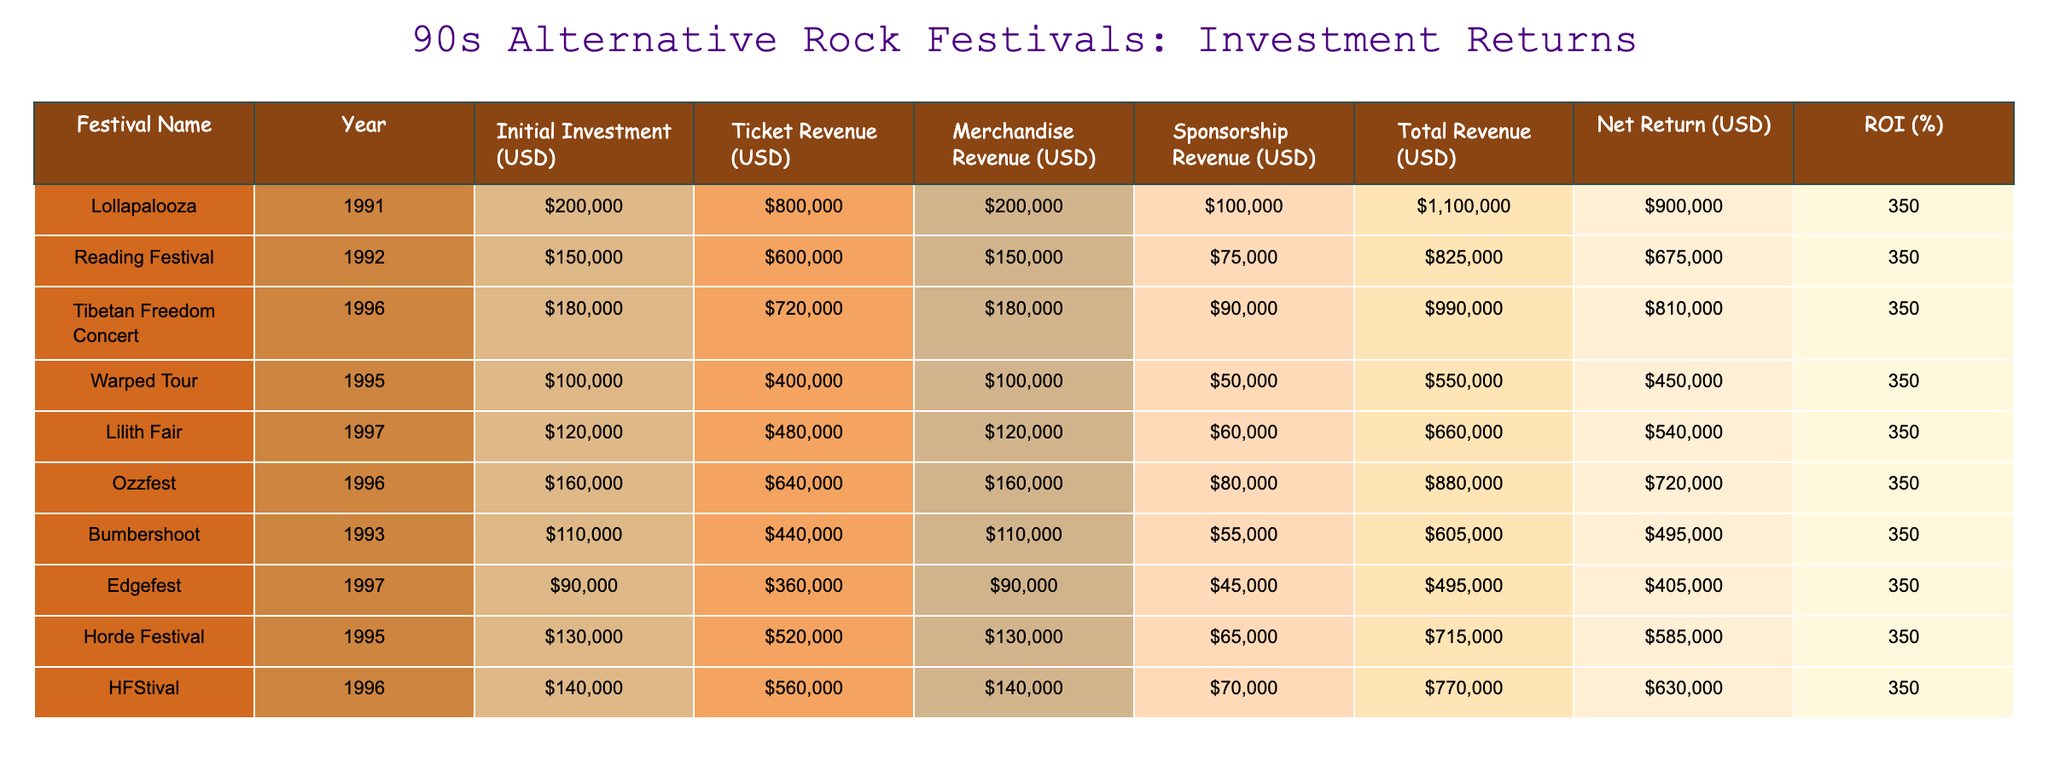What is the highest Net Return among the festivals? By looking at the 'Net Return (USD)' column, we find that Lollapalooza has the highest value at 900,000 USD.
Answer: 900000 Which festival had the lowest Initial Investment? The 'Initial Investment (USD)' column shows that Edgefest had the lowest investment amount at 90,000 USD.
Answer: 90000 What is the average Total Revenue of all the festivals? First, we sum the 'Total Revenue (USD)' values: (1,100,000 + 825,000 + 990,000 + 550,000 + 660,000 + 880,000 + 605,000 + 495,000 + 770,000) = 6,975,000 USD. Since there are 9 festivals, the average is 6,975,000 / 9 = 775,000 USD.
Answer: 775000 Did any festival achieve a Net Return exceeding 600,000 USD? By examining the 'Net Return (USD)' values, we see that Lollapalooza, Reading Festival, Tibetan Freedom Concert, Ozzfest, and Lilith Fair all exceed 600,000 USD, confirming that there are festivals which did achieve this.
Answer: Yes What is the difference in Total Revenue between Lollapalooza and Warped Tour? The Total Revenue for Lollapalooza is 1,100,000 USD and for Warped Tour it is 550,000 USD. The difference is 1,100,000 - 550,000 = 550,000 USD.
Answer: 550000 Which festival had the highest Merchandise Revenue? Looking at the 'Merchandise Revenue (USD)' column, we identify that Ozzfest has the highest amount at 160,000 USD.
Answer: 160000 What was the Total Revenue for the festival with the second highest Net Return? After identifying that Lollapalooza has the highest Net Return and the second highest is Tibetan Freedom Concert at 810,000 USD, the Total Revenue for this festival is 990,000 USD.
Answer: 990000 What percentage of the Initial Investment did Edgefest earn as a return? Edgefest's Net Return is 405,000 USD with an Initial Investment of 90,000 USD. The calculation for ROI is: ((405,000 - 90,000) / 90,000) * 100 = 350%.
Answer: 350% 